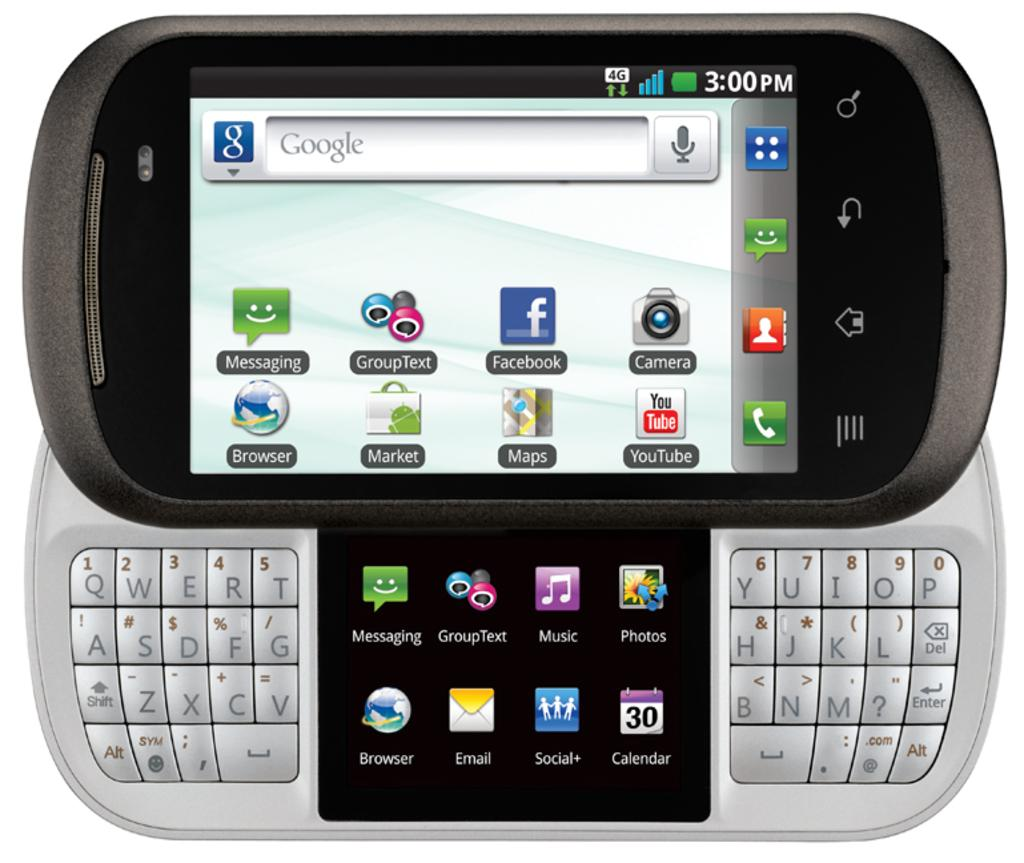<image>
Present a compact description of the photo's key features. some apps that include a messaging app on it 